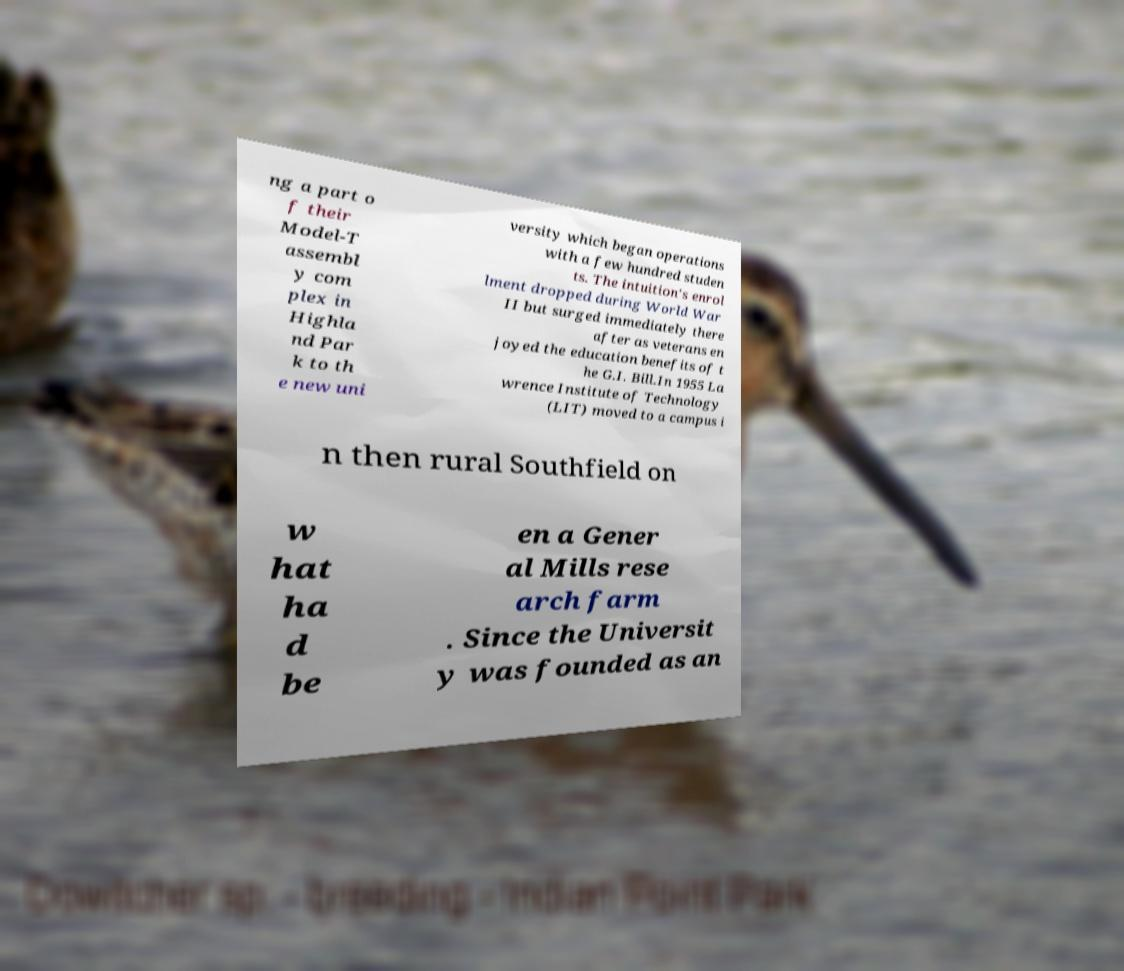Can you read and provide the text displayed in the image?This photo seems to have some interesting text. Can you extract and type it out for me? ng a part o f their Model-T assembl y com plex in Highla nd Par k to th e new uni versity which began operations with a few hundred studen ts. The intuition's enrol lment dropped during World War II but surged immediately there after as veterans en joyed the education benefits of t he G.I. Bill.In 1955 La wrence Institute of Technology (LIT) moved to a campus i n then rural Southfield on w hat ha d be en a Gener al Mills rese arch farm . Since the Universit y was founded as an 